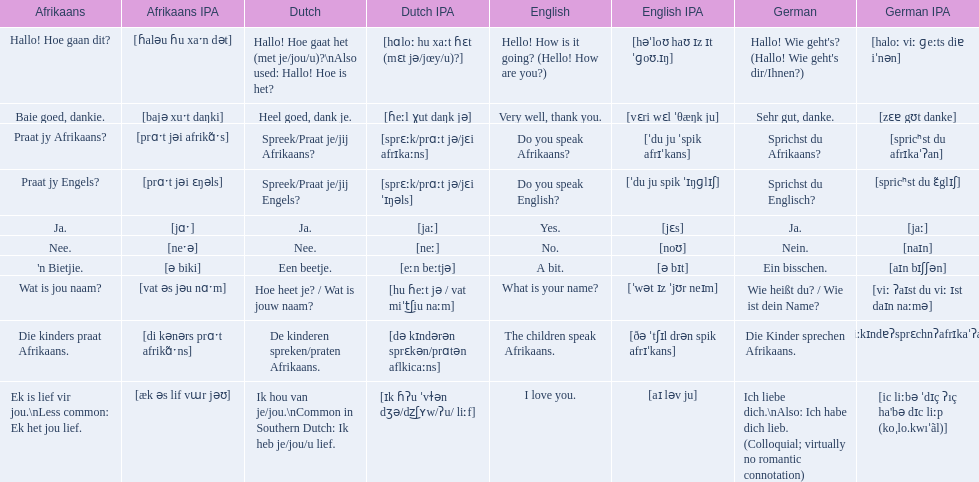Which phrases are said in africaans? Hallo! Hoe gaan dit?, Baie goed, dankie., Praat jy Afrikaans?, Praat jy Engels?, Ja., Nee., 'n Bietjie., Wat is jou naam?, Die kinders praat Afrikaans., Ek is lief vir jou.\nLess common: Ek het jou lief. Which of these mean how do you speak afrikaans? Praat jy Afrikaans?. 